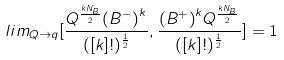Convert formula to latex. <formula><loc_0><loc_0><loc_500><loc_500>l i m _ { Q \to q } [ { { \frac { Q ^ { \frac { k N _ { B } } { 2 } } { ( B ^ { - } ) } ^ { k } } { ( [ k ] ! ) ^ { \frac { 1 } { 2 } } } } , { { \frac { { ( B ^ { + } ) } ^ { k } Q ^ { { \frac { k N _ { B } } { 2 } } } } { ( [ k ] ! ) ^ { \frac { 1 } { 2 } } } } } } ] = 1</formula> 